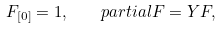Convert formula to latex. <formula><loc_0><loc_0><loc_500><loc_500>F _ { [ 0 ] } = 1 , \ \ \ p a r t i a l F = Y F ,</formula> 